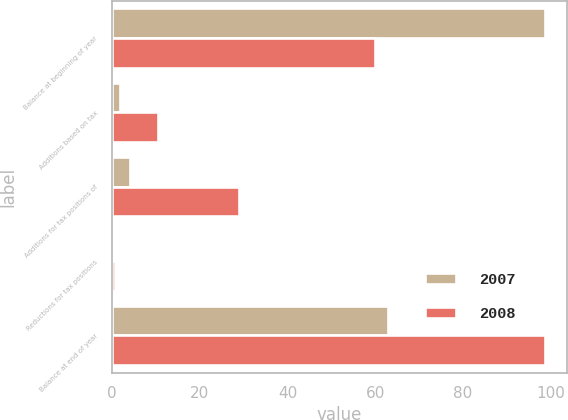Convert chart to OTSL. <chart><loc_0><loc_0><loc_500><loc_500><stacked_bar_chart><ecel><fcel>Balance at beginning of year<fcel>Additions based on tax<fcel>Additions for tax positions of<fcel>Reductions for tax positions<fcel>Balance at end of year<nl><fcel>2007<fcel>98.8<fcel>1.7<fcel>4.1<fcel>0.3<fcel>62.9<nl><fcel>2008<fcel>60<fcel>10.4<fcel>29<fcel>0.6<fcel>98.8<nl></chart> 